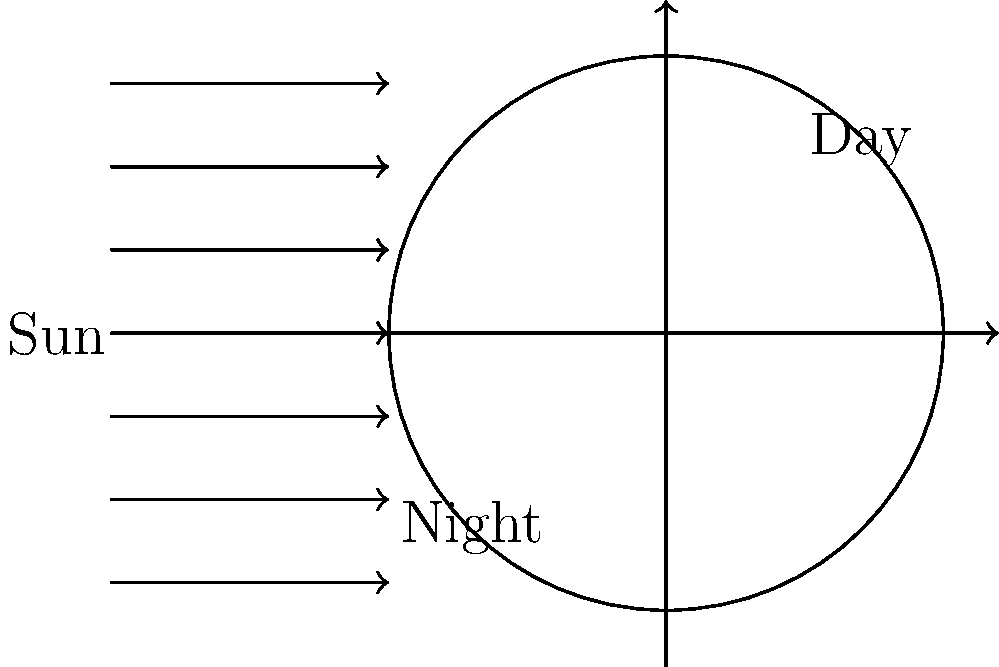As a former NHL player, you understand the importance of timing and cycles in sports. In astronomy, the Earth's rotation creates a similar cycle. If the Earth were to suddenly rotate twice as fast, how would this affect the duration of daylight at your hockey equipment store? To understand how a faster Earth rotation would affect daylight duration, let's break it down step-by-step:

1. Earth's current rotation:
   - The Earth completes one full rotation on its axis in approximately 24 hours.
   - This rotation is what gives us our day-night cycle.

2. Day-night cycle:
   - One full rotation (360°) = 24 hours
   - Half rotation (180°) = 12 hours (roughly split between day and night)

3. Effect of doubling rotation speed:
   - If Earth rotates twice as fast, it will complete one full rotation in 12 hours instead of 24.
   - The formula would be: $\text{New rotation time} = \frac{\text{Current rotation time}}{2} = \frac{24 \text{ hours}}{2} = 12 \text{ hours}$

4. New day-night cycle:
   - One full rotation (360°) = 12 hours
   - Half rotation (180°) = 6 hours

5. Daylight duration:
   - Currently, daylight lasts approximately 12 hours (varies with seasons and location).
   - With the faster rotation, daylight would last approximately 6 hours.

6. Conclusion:
   - The duration of daylight at your hockey equipment store would be reduced by half, from about 12 hours to about 6 hours.

This change would significantly impact daily routines, including store opening hours and hockey practice schedules.
Answer: Daylight duration would be reduced by half, to approximately 6 hours. 